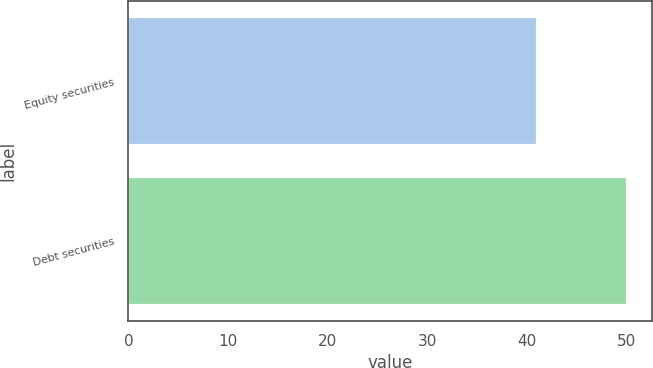Convert chart. <chart><loc_0><loc_0><loc_500><loc_500><bar_chart><fcel>Equity securities<fcel>Debt securities<nl><fcel>41<fcel>50<nl></chart> 